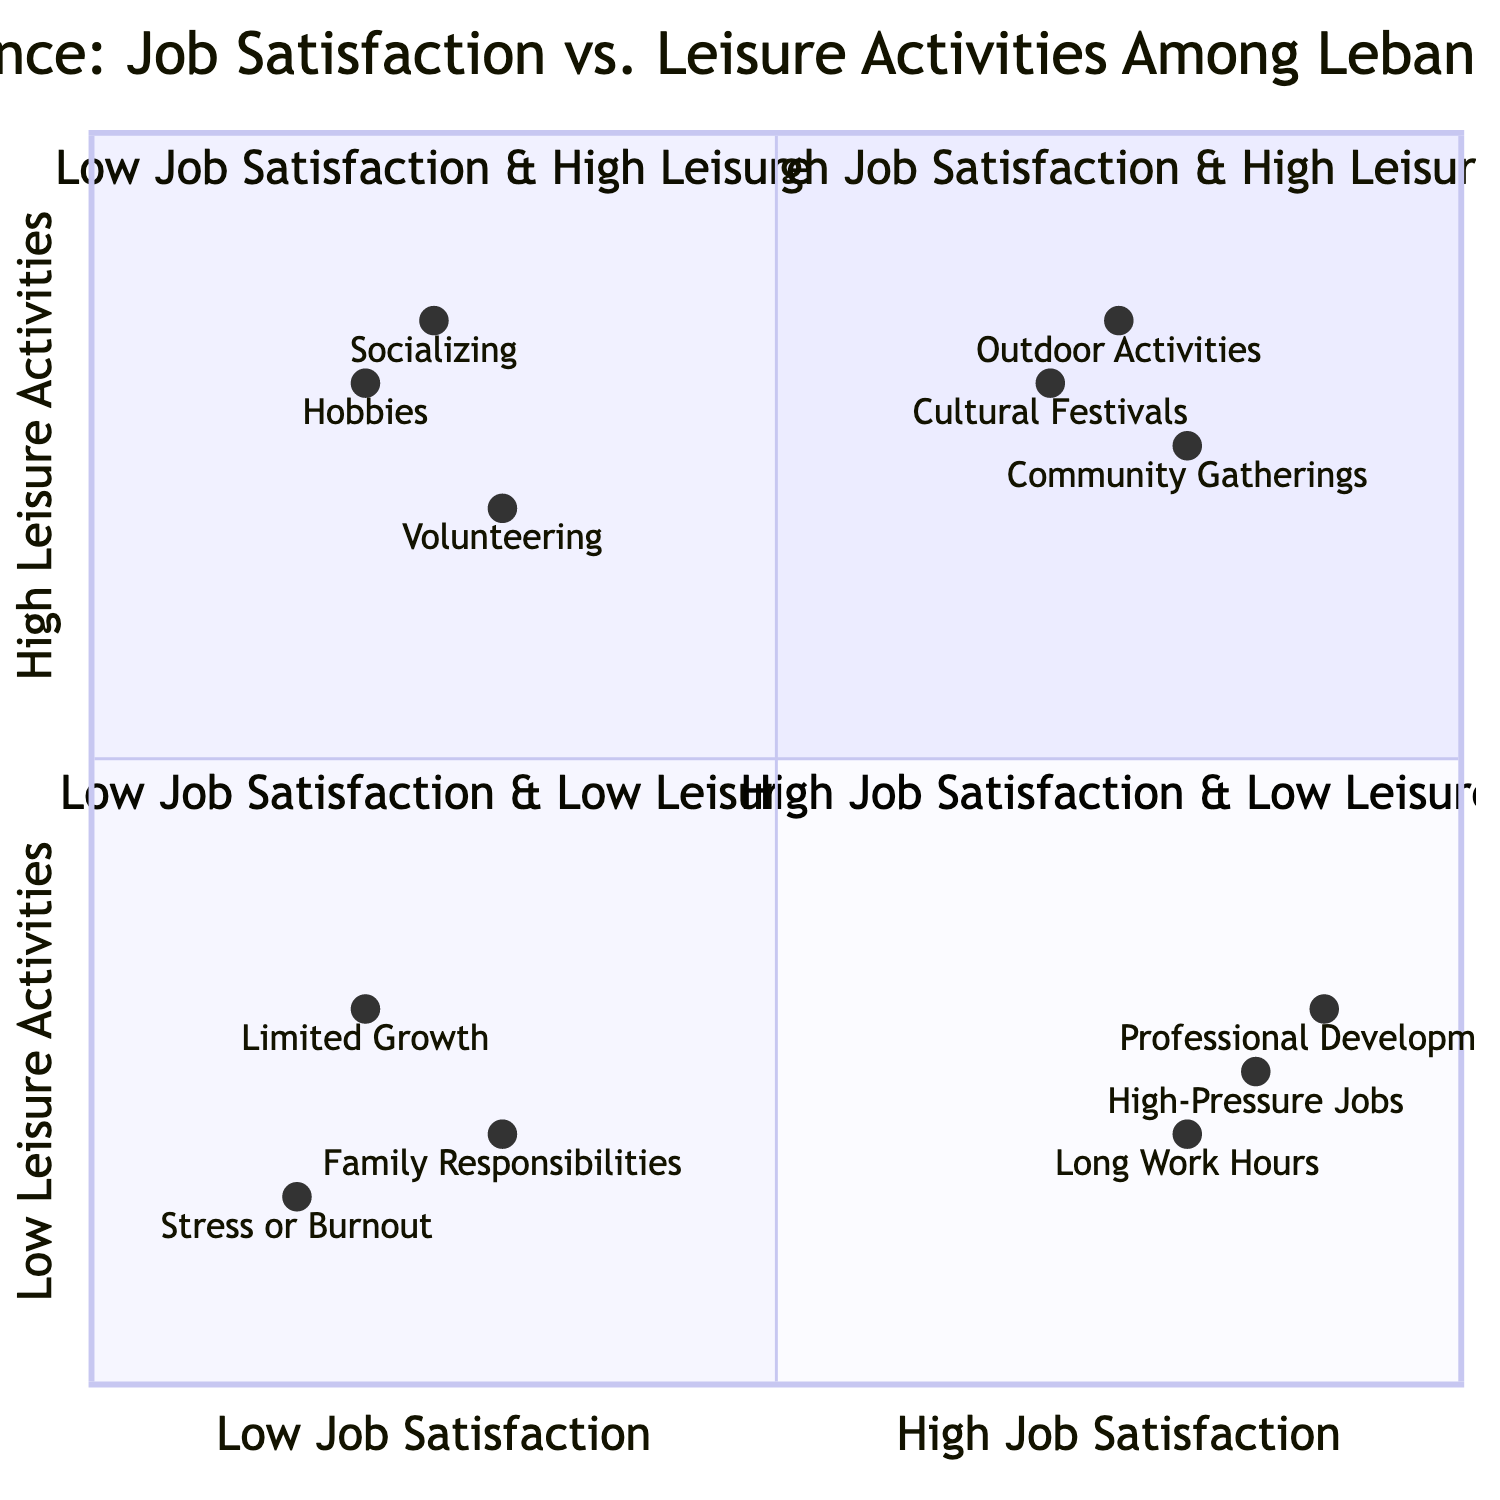What elements are located in the High Job Satisfaction & High Leisure Activities quadrant? By examining the quadrant labeled "High Job Satisfaction & High Leisure Activities," we can identify the elements positioned within this area: Attending Cultural Festivals, Community Gatherings, and Outdoor Activities.
Answer: Attending Cultural Festivals, Community Gatherings, Outdoor Activities How many elements are in the Low Job Satisfaction & Low Leisure Activities quadrant? Count the number of elements listed in the "Low Job Satisfaction & Low Leisure Activities" quadrant. There are three elements: Limited Professional Growth, Family Responsibilities, and Stress or Burnout.
Answer: 3 What is one example of an activity in the Low Job Satisfaction & High Leisure Activities quadrant? The "Low Job Satisfaction & High Leisure Activities" quadrant includes activities such as Volunteering, which is given as an example of a leisure activity despite low job satisfaction.
Answer: Volunteering Which quadrant contains Professional Development? Professional Development is listed in the "High Job Satisfaction & Low Leisure Activities" quadrant, indicating that it falls within the area of high job satisfaction but low leisure activities.
Answer: High Job Satisfaction & Low Leisure Activities Which element has the highest score for leisure activities? Looking at the scores, Outdoor Activities has a leisure score of 0.85, which is the highest among all activities.
Answer: Outdoor Activities Which two activities are associated with High Job Satisfaction but Low Leisure Activities? In the "High Job Satisfaction & Low Leisure Activities" quadrant, both Long Work Hours and High-Pressure Jobs are linked to job satisfaction without much leisure involvement.
Answer: Long Work Hours, High-Pressure Jobs What is the representation of Socializing on the chart? Socializing is positioned in the "Low Job Satisfaction & High Leisure Activities" quadrant with a specific coordinate that indicates its level of job satisfaction and leisure activity participation, which conveys moderate satisfaction and high leisure involvement.
Answer: Low Job Satisfaction & High Leisure Activities Which quadrant would you find High-Pressure Jobs in? High-Pressure Jobs is located in the "High Job Satisfaction & Low Leisure Activities" quadrant, showing a trend where such jobs can lead to satisfaction but might not provide leisure time.
Answer: High Job Satisfaction & Low Leisure Activities What does the presence of Stress or Burnout signify in the diagram? Stress or Burnout is found in the "Low Job Satisfaction & Low Leisure Activities" quadrant, which indicates that these factors are associated with both low job satisfaction and limited leisure activities.
Answer: Low Job Satisfaction & Low Leisure Activities 